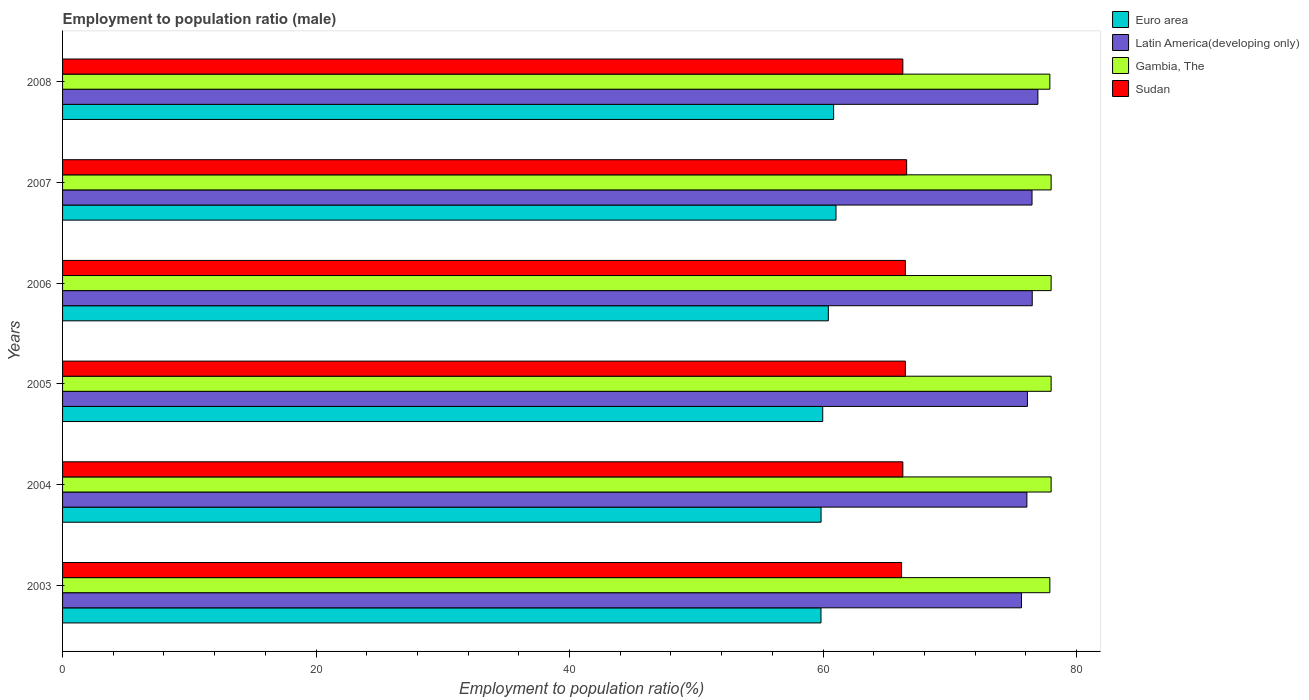How many groups of bars are there?
Give a very brief answer. 6. Are the number of bars per tick equal to the number of legend labels?
Keep it short and to the point. Yes. Are the number of bars on each tick of the Y-axis equal?
Provide a succinct answer. Yes. How many bars are there on the 6th tick from the top?
Offer a terse response. 4. How many bars are there on the 4th tick from the bottom?
Offer a very short reply. 4. In how many cases, is the number of bars for a given year not equal to the number of legend labels?
Provide a short and direct response. 0. What is the employment to population ratio in Sudan in 2004?
Give a very brief answer. 66.3. Across all years, what is the maximum employment to population ratio in Sudan?
Your answer should be compact. 66.6. Across all years, what is the minimum employment to population ratio in Latin America(developing only)?
Offer a terse response. 75.66. What is the total employment to population ratio in Euro area in the graph?
Give a very brief answer. 361.95. What is the difference between the employment to population ratio in Euro area in 2003 and that in 2004?
Give a very brief answer. -0.01. What is the difference between the employment to population ratio in Euro area in 2004 and the employment to population ratio in Gambia, The in 2008?
Your response must be concise. -18.05. What is the average employment to population ratio in Gambia, The per year?
Ensure brevity in your answer.  77.97. In the year 2006, what is the difference between the employment to population ratio in Gambia, The and employment to population ratio in Sudan?
Your answer should be very brief. 11.5. What is the ratio of the employment to population ratio in Sudan in 2003 to that in 2006?
Provide a succinct answer. 1. Is the employment to population ratio in Euro area in 2003 less than that in 2005?
Make the answer very short. Yes. What is the difference between the highest and the second highest employment to population ratio in Sudan?
Your answer should be very brief. 0.1. What is the difference between the highest and the lowest employment to population ratio in Euro area?
Your answer should be compact. 1.18. In how many years, is the employment to population ratio in Sudan greater than the average employment to population ratio in Sudan taken over all years?
Keep it short and to the point. 3. Is the sum of the employment to population ratio in Sudan in 2003 and 2007 greater than the maximum employment to population ratio in Latin America(developing only) across all years?
Your response must be concise. Yes. What does the 3rd bar from the top in 2003 represents?
Your answer should be very brief. Latin America(developing only). What does the 3rd bar from the bottom in 2005 represents?
Your response must be concise. Gambia, The. Is it the case that in every year, the sum of the employment to population ratio in Sudan and employment to population ratio in Euro area is greater than the employment to population ratio in Latin America(developing only)?
Give a very brief answer. Yes. How many bars are there?
Give a very brief answer. 24. Are all the bars in the graph horizontal?
Give a very brief answer. Yes. How many years are there in the graph?
Ensure brevity in your answer.  6. What is the difference between two consecutive major ticks on the X-axis?
Provide a short and direct response. 20. Does the graph contain any zero values?
Your response must be concise. No. Does the graph contain grids?
Provide a succinct answer. No. What is the title of the graph?
Provide a succinct answer. Employment to population ratio (male). What is the Employment to population ratio(%) of Euro area in 2003?
Your response must be concise. 59.84. What is the Employment to population ratio(%) of Latin America(developing only) in 2003?
Give a very brief answer. 75.66. What is the Employment to population ratio(%) in Gambia, The in 2003?
Ensure brevity in your answer.  77.9. What is the Employment to population ratio(%) of Sudan in 2003?
Your answer should be very brief. 66.2. What is the Employment to population ratio(%) in Euro area in 2004?
Your response must be concise. 59.85. What is the Employment to population ratio(%) of Latin America(developing only) in 2004?
Make the answer very short. 76.09. What is the Employment to population ratio(%) in Sudan in 2004?
Your response must be concise. 66.3. What is the Employment to population ratio(%) of Euro area in 2005?
Your response must be concise. 59.98. What is the Employment to population ratio(%) in Latin America(developing only) in 2005?
Provide a succinct answer. 76.13. What is the Employment to population ratio(%) in Gambia, The in 2005?
Offer a terse response. 78. What is the Employment to population ratio(%) in Sudan in 2005?
Provide a short and direct response. 66.5. What is the Employment to population ratio(%) in Euro area in 2006?
Offer a terse response. 60.42. What is the Employment to population ratio(%) in Latin America(developing only) in 2006?
Offer a terse response. 76.51. What is the Employment to population ratio(%) in Gambia, The in 2006?
Make the answer very short. 78. What is the Employment to population ratio(%) of Sudan in 2006?
Your response must be concise. 66.5. What is the Employment to population ratio(%) of Euro area in 2007?
Provide a succinct answer. 61.03. What is the Employment to population ratio(%) of Latin America(developing only) in 2007?
Offer a very short reply. 76.49. What is the Employment to population ratio(%) of Gambia, The in 2007?
Your response must be concise. 78. What is the Employment to population ratio(%) in Sudan in 2007?
Ensure brevity in your answer.  66.6. What is the Employment to population ratio(%) in Euro area in 2008?
Provide a succinct answer. 60.84. What is the Employment to population ratio(%) in Latin America(developing only) in 2008?
Offer a terse response. 76.96. What is the Employment to population ratio(%) in Gambia, The in 2008?
Give a very brief answer. 77.9. What is the Employment to population ratio(%) in Sudan in 2008?
Offer a terse response. 66.3. Across all years, what is the maximum Employment to population ratio(%) of Euro area?
Keep it short and to the point. 61.03. Across all years, what is the maximum Employment to population ratio(%) in Latin America(developing only)?
Provide a short and direct response. 76.96. Across all years, what is the maximum Employment to population ratio(%) in Gambia, The?
Offer a terse response. 78. Across all years, what is the maximum Employment to population ratio(%) of Sudan?
Offer a terse response. 66.6. Across all years, what is the minimum Employment to population ratio(%) of Euro area?
Ensure brevity in your answer.  59.84. Across all years, what is the minimum Employment to population ratio(%) in Latin America(developing only)?
Your answer should be compact. 75.66. Across all years, what is the minimum Employment to population ratio(%) in Gambia, The?
Provide a succinct answer. 77.9. Across all years, what is the minimum Employment to population ratio(%) in Sudan?
Provide a short and direct response. 66.2. What is the total Employment to population ratio(%) in Euro area in the graph?
Provide a short and direct response. 361.95. What is the total Employment to population ratio(%) in Latin America(developing only) in the graph?
Keep it short and to the point. 457.84. What is the total Employment to population ratio(%) of Gambia, The in the graph?
Your answer should be compact. 467.8. What is the total Employment to population ratio(%) in Sudan in the graph?
Keep it short and to the point. 398.4. What is the difference between the Employment to population ratio(%) in Euro area in 2003 and that in 2004?
Make the answer very short. -0.01. What is the difference between the Employment to population ratio(%) of Latin America(developing only) in 2003 and that in 2004?
Make the answer very short. -0.43. What is the difference between the Employment to population ratio(%) in Euro area in 2003 and that in 2005?
Provide a short and direct response. -0.14. What is the difference between the Employment to population ratio(%) of Latin America(developing only) in 2003 and that in 2005?
Make the answer very short. -0.47. What is the difference between the Employment to population ratio(%) of Gambia, The in 2003 and that in 2005?
Provide a short and direct response. -0.1. What is the difference between the Employment to population ratio(%) in Euro area in 2003 and that in 2006?
Offer a terse response. -0.58. What is the difference between the Employment to population ratio(%) of Latin America(developing only) in 2003 and that in 2006?
Offer a very short reply. -0.85. What is the difference between the Employment to population ratio(%) in Gambia, The in 2003 and that in 2006?
Ensure brevity in your answer.  -0.1. What is the difference between the Employment to population ratio(%) in Euro area in 2003 and that in 2007?
Offer a terse response. -1.18. What is the difference between the Employment to population ratio(%) of Latin America(developing only) in 2003 and that in 2007?
Ensure brevity in your answer.  -0.83. What is the difference between the Employment to population ratio(%) in Gambia, The in 2003 and that in 2007?
Ensure brevity in your answer.  -0.1. What is the difference between the Employment to population ratio(%) in Euro area in 2003 and that in 2008?
Make the answer very short. -1. What is the difference between the Employment to population ratio(%) of Latin America(developing only) in 2003 and that in 2008?
Your answer should be very brief. -1.29. What is the difference between the Employment to population ratio(%) of Sudan in 2003 and that in 2008?
Ensure brevity in your answer.  -0.1. What is the difference between the Employment to population ratio(%) in Euro area in 2004 and that in 2005?
Provide a short and direct response. -0.13. What is the difference between the Employment to population ratio(%) of Latin America(developing only) in 2004 and that in 2005?
Your response must be concise. -0.04. What is the difference between the Employment to population ratio(%) of Gambia, The in 2004 and that in 2005?
Make the answer very short. 0. What is the difference between the Employment to population ratio(%) of Euro area in 2004 and that in 2006?
Offer a very short reply. -0.57. What is the difference between the Employment to population ratio(%) of Latin America(developing only) in 2004 and that in 2006?
Provide a succinct answer. -0.42. What is the difference between the Employment to population ratio(%) of Euro area in 2004 and that in 2007?
Offer a very short reply. -1.18. What is the difference between the Employment to population ratio(%) in Latin America(developing only) in 2004 and that in 2007?
Give a very brief answer. -0.41. What is the difference between the Employment to population ratio(%) in Gambia, The in 2004 and that in 2007?
Make the answer very short. 0. What is the difference between the Employment to population ratio(%) in Euro area in 2004 and that in 2008?
Your response must be concise. -0.99. What is the difference between the Employment to population ratio(%) in Latin America(developing only) in 2004 and that in 2008?
Provide a succinct answer. -0.87. What is the difference between the Employment to population ratio(%) of Sudan in 2004 and that in 2008?
Ensure brevity in your answer.  0. What is the difference between the Employment to population ratio(%) of Euro area in 2005 and that in 2006?
Your answer should be compact. -0.44. What is the difference between the Employment to population ratio(%) of Latin America(developing only) in 2005 and that in 2006?
Provide a short and direct response. -0.38. What is the difference between the Employment to population ratio(%) of Gambia, The in 2005 and that in 2006?
Offer a terse response. 0. What is the difference between the Employment to population ratio(%) in Euro area in 2005 and that in 2007?
Your answer should be compact. -1.05. What is the difference between the Employment to population ratio(%) in Latin America(developing only) in 2005 and that in 2007?
Offer a terse response. -0.36. What is the difference between the Employment to population ratio(%) of Euro area in 2005 and that in 2008?
Provide a succinct answer. -0.86. What is the difference between the Employment to population ratio(%) of Latin America(developing only) in 2005 and that in 2008?
Keep it short and to the point. -0.83. What is the difference between the Employment to population ratio(%) in Gambia, The in 2005 and that in 2008?
Keep it short and to the point. 0.1. What is the difference between the Employment to population ratio(%) in Euro area in 2006 and that in 2007?
Your answer should be compact. -0.6. What is the difference between the Employment to population ratio(%) of Latin America(developing only) in 2006 and that in 2007?
Your answer should be very brief. 0.02. What is the difference between the Employment to population ratio(%) of Euro area in 2006 and that in 2008?
Provide a short and direct response. -0.42. What is the difference between the Employment to population ratio(%) of Latin America(developing only) in 2006 and that in 2008?
Offer a terse response. -0.45. What is the difference between the Employment to population ratio(%) of Sudan in 2006 and that in 2008?
Offer a very short reply. 0.2. What is the difference between the Employment to population ratio(%) of Euro area in 2007 and that in 2008?
Offer a terse response. 0.19. What is the difference between the Employment to population ratio(%) of Latin America(developing only) in 2007 and that in 2008?
Ensure brevity in your answer.  -0.46. What is the difference between the Employment to population ratio(%) in Sudan in 2007 and that in 2008?
Make the answer very short. 0.3. What is the difference between the Employment to population ratio(%) in Euro area in 2003 and the Employment to population ratio(%) in Latin America(developing only) in 2004?
Provide a succinct answer. -16.25. What is the difference between the Employment to population ratio(%) of Euro area in 2003 and the Employment to population ratio(%) of Gambia, The in 2004?
Make the answer very short. -18.16. What is the difference between the Employment to population ratio(%) of Euro area in 2003 and the Employment to population ratio(%) of Sudan in 2004?
Keep it short and to the point. -6.46. What is the difference between the Employment to population ratio(%) in Latin America(developing only) in 2003 and the Employment to population ratio(%) in Gambia, The in 2004?
Provide a succinct answer. -2.34. What is the difference between the Employment to population ratio(%) of Latin America(developing only) in 2003 and the Employment to population ratio(%) of Sudan in 2004?
Your response must be concise. 9.36. What is the difference between the Employment to population ratio(%) in Euro area in 2003 and the Employment to population ratio(%) in Latin America(developing only) in 2005?
Provide a succinct answer. -16.29. What is the difference between the Employment to population ratio(%) of Euro area in 2003 and the Employment to population ratio(%) of Gambia, The in 2005?
Make the answer very short. -18.16. What is the difference between the Employment to population ratio(%) of Euro area in 2003 and the Employment to population ratio(%) of Sudan in 2005?
Offer a very short reply. -6.66. What is the difference between the Employment to population ratio(%) in Latin America(developing only) in 2003 and the Employment to population ratio(%) in Gambia, The in 2005?
Provide a succinct answer. -2.34. What is the difference between the Employment to population ratio(%) of Latin America(developing only) in 2003 and the Employment to population ratio(%) of Sudan in 2005?
Offer a terse response. 9.16. What is the difference between the Employment to population ratio(%) of Euro area in 2003 and the Employment to population ratio(%) of Latin America(developing only) in 2006?
Give a very brief answer. -16.67. What is the difference between the Employment to population ratio(%) of Euro area in 2003 and the Employment to population ratio(%) of Gambia, The in 2006?
Your answer should be very brief. -18.16. What is the difference between the Employment to population ratio(%) in Euro area in 2003 and the Employment to population ratio(%) in Sudan in 2006?
Provide a short and direct response. -6.66. What is the difference between the Employment to population ratio(%) in Latin America(developing only) in 2003 and the Employment to population ratio(%) in Gambia, The in 2006?
Make the answer very short. -2.34. What is the difference between the Employment to population ratio(%) in Latin America(developing only) in 2003 and the Employment to population ratio(%) in Sudan in 2006?
Keep it short and to the point. 9.16. What is the difference between the Employment to population ratio(%) in Euro area in 2003 and the Employment to population ratio(%) in Latin America(developing only) in 2007?
Offer a very short reply. -16.65. What is the difference between the Employment to population ratio(%) in Euro area in 2003 and the Employment to population ratio(%) in Gambia, The in 2007?
Offer a very short reply. -18.16. What is the difference between the Employment to population ratio(%) in Euro area in 2003 and the Employment to population ratio(%) in Sudan in 2007?
Your answer should be compact. -6.76. What is the difference between the Employment to population ratio(%) in Latin America(developing only) in 2003 and the Employment to population ratio(%) in Gambia, The in 2007?
Provide a short and direct response. -2.34. What is the difference between the Employment to population ratio(%) in Latin America(developing only) in 2003 and the Employment to population ratio(%) in Sudan in 2007?
Your answer should be very brief. 9.06. What is the difference between the Employment to population ratio(%) in Euro area in 2003 and the Employment to population ratio(%) in Latin America(developing only) in 2008?
Give a very brief answer. -17.11. What is the difference between the Employment to population ratio(%) in Euro area in 2003 and the Employment to population ratio(%) in Gambia, The in 2008?
Your answer should be very brief. -18.06. What is the difference between the Employment to population ratio(%) in Euro area in 2003 and the Employment to population ratio(%) in Sudan in 2008?
Your answer should be compact. -6.46. What is the difference between the Employment to population ratio(%) of Latin America(developing only) in 2003 and the Employment to population ratio(%) of Gambia, The in 2008?
Your answer should be compact. -2.24. What is the difference between the Employment to population ratio(%) of Latin America(developing only) in 2003 and the Employment to population ratio(%) of Sudan in 2008?
Ensure brevity in your answer.  9.36. What is the difference between the Employment to population ratio(%) of Euro area in 2004 and the Employment to population ratio(%) of Latin America(developing only) in 2005?
Provide a succinct answer. -16.28. What is the difference between the Employment to population ratio(%) in Euro area in 2004 and the Employment to population ratio(%) in Gambia, The in 2005?
Make the answer very short. -18.15. What is the difference between the Employment to population ratio(%) in Euro area in 2004 and the Employment to population ratio(%) in Sudan in 2005?
Your response must be concise. -6.65. What is the difference between the Employment to population ratio(%) in Latin America(developing only) in 2004 and the Employment to population ratio(%) in Gambia, The in 2005?
Offer a very short reply. -1.91. What is the difference between the Employment to population ratio(%) of Latin America(developing only) in 2004 and the Employment to population ratio(%) of Sudan in 2005?
Your answer should be compact. 9.59. What is the difference between the Employment to population ratio(%) in Euro area in 2004 and the Employment to population ratio(%) in Latin America(developing only) in 2006?
Give a very brief answer. -16.66. What is the difference between the Employment to population ratio(%) of Euro area in 2004 and the Employment to population ratio(%) of Gambia, The in 2006?
Keep it short and to the point. -18.15. What is the difference between the Employment to population ratio(%) in Euro area in 2004 and the Employment to population ratio(%) in Sudan in 2006?
Your response must be concise. -6.65. What is the difference between the Employment to population ratio(%) of Latin America(developing only) in 2004 and the Employment to population ratio(%) of Gambia, The in 2006?
Make the answer very short. -1.91. What is the difference between the Employment to population ratio(%) of Latin America(developing only) in 2004 and the Employment to population ratio(%) of Sudan in 2006?
Keep it short and to the point. 9.59. What is the difference between the Employment to population ratio(%) of Gambia, The in 2004 and the Employment to population ratio(%) of Sudan in 2006?
Your response must be concise. 11.5. What is the difference between the Employment to population ratio(%) in Euro area in 2004 and the Employment to population ratio(%) in Latin America(developing only) in 2007?
Provide a short and direct response. -16.65. What is the difference between the Employment to population ratio(%) in Euro area in 2004 and the Employment to population ratio(%) in Gambia, The in 2007?
Give a very brief answer. -18.15. What is the difference between the Employment to population ratio(%) in Euro area in 2004 and the Employment to population ratio(%) in Sudan in 2007?
Keep it short and to the point. -6.75. What is the difference between the Employment to population ratio(%) in Latin America(developing only) in 2004 and the Employment to population ratio(%) in Gambia, The in 2007?
Offer a terse response. -1.91. What is the difference between the Employment to population ratio(%) in Latin America(developing only) in 2004 and the Employment to population ratio(%) in Sudan in 2007?
Ensure brevity in your answer.  9.49. What is the difference between the Employment to population ratio(%) in Gambia, The in 2004 and the Employment to population ratio(%) in Sudan in 2007?
Your answer should be compact. 11.4. What is the difference between the Employment to population ratio(%) in Euro area in 2004 and the Employment to population ratio(%) in Latin America(developing only) in 2008?
Your response must be concise. -17.11. What is the difference between the Employment to population ratio(%) in Euro area in 2004 and the Employment to population ratio(%) in Gambia, The in 2008?
Provide a succinct answer. -18.05. What is the difference between the Employment to population ratio(%) in Euro area in 2004 and the Employment to population ratio(%) in Sudan in 2008?
Your response must be concise. -6.45. What is the difference between the Employment to population ratio(%) in Latin America(developing only) in 2004 and the Employment to population ratio(%) in Gambia, The in 2008?
Ensure brevity in your answer.  -1.81. What is the difference between the Employment to population ratio(%) in Latin America(developing only) in 2004 and the Employment to population ratio(%) in Sudan in 2008?
Give a very brief answer. 9.79. What is the difference between the Employment to population ratio(%) of Gambia, The in 2004 and the Employment to population ratio(%) of Sudan in 2008?
Keep it short and to the point. 11.7. What is the difference between the Employment to population ratio(%) in Euro area in 2005 and the Employment to population ratio(%) in Latin America(developing only) in 2006?
Keep it short and to the point. -16.53. What is the difference between the Employment to population ratio(%) of Euro area in 2005 and the Employment to population ratio(%) of Gambia, The in 2006?
Provide a succinct answer. -18.02. What is the difference between the Employment to population ratio(%) in Euro area in 2005 and the Employment to population ratio(%) in Sudan in 2006?
Offer a terse response. -6.52. What is the difference between the Employment to population ratio(%) in Latin America(developing only) in 2005 and the Employment to population ratio(%) in Gambia, The in 2006?
Ensure brevity in your answer.  -1.87. What is the difference between the Employment to population ratio(%) in Latin America(developing only) in 2005 and the Employment to population ratio(%) in Sudan in 2006?
Offer a very short reply. 9.63. What is the difference between the Employment to population ratio(%) in Euro area in 2005 and the Employment to population ratio(%) in Latin America(developing only) in 2007?
Your answer should be very brief. -16.52. What is the difference between the Employment to population ratio(%) in Euro area in 2005 and the Employment to population ratio(%) in Gambia, The in 2007?
Your response must be concise. -18.02. What is the difference between the Employment to population ratio(%) of Euro area in 2005 and the Employment to population ratio(%) of Sudan in 2007?
Make the answer very short. -6.62. What is the difference between the Employment to population ratio(%) of Latin America(developing only) in 2005 and the Employment to population ratio(%) of Gambia, The in 2007?
Your answer should be compact. -1.87. What is the difference between the Employment to population ratio(%) in Latin America(developing only) in 2005 and the Employment to population ratio(%) in Sudan in 2007?
Give a very brief answer. 9.53. What is the difference between the Employment to population ratio(%) of Gambia, The in 2005 and the Employment to population ratio(%) of Sudan in 2007?
Keep it short and to the point. 11.4. What is the difference between the Employment to population ratio(%) of Euro area in 2005 and the Employment to population ratio(%) of Latin America(developing only) in 2008?
Provide a short and direct response. -16.98. What is the difference between the Employment to population ratio(%) of Euro area in 2005 and the Employment to population ratio(%) of Gambia, The in 2008?
Give a very brief answer. -17.92. What is the difference between the Employment to population ratio(%) in Euro area in 2005 and the Employment to population ratio(%) in Sudan in 2008?
Offer a terse response. -6.32. What is the difference between the Employment to population ratio(%) of Latin America(developing only) in 2005 and the Employment to population ratio(%) of Gambia, The in 2008?
Make the answer very short. -1.77. What is the difference between the Employment to population ratio(%) of Latin America(developing only) in 2005 and the Employment to population ratio(%) of Sudan in 2008?
Your response must be concise. 9.83. What is the difference between the Employment to population ratio(%) in Gambia, The in 2005 and the Employment to population ratio(%) in Sudan in 2008?
Give a very brief answer. 11.7. What is the difference between the Employment to population ratio(%) of Euro area in 2006 and the Employment to population ratio(%) of Latin America(developing only) in 2007?
Give a very brief answer. -16.07. What is the difference between the Employment to population ratio(%) in Euro area in 2006 and the Employment to population ratio(%) in Gambia, The in 2007?
Your answer should be compact. -17.58. What is the difference between the Employment to population ratio(%) in Euro area in 2006 and the Employment to population ratio(%) in Sudan in 2007?
Your answer should be compact. -6.18. What is the difference between the Employment to population ratio(%) of Latin America(developing only) in 2006 and the Employment to population ratio(%) of Gambia, The in 2007?
Keep it short and to the point. -1.49. What is the difference between the Employment to population ratio(%) of Latin America(developing only) in 2006 and the Employment to population ratio(%) of Sudan in 2007?
Your answer should be very brief. 9.91. What is the difference between the Employment to population ratio(%) in Gambia, The in 2006 and the Employment to population ratio(%) in Sudan in 2007?
Make the answer very short. 11.4. What is the difference between the Employment to population ratio(%) in Euro area in 2006 and the Employment to population ratio(%) in Latin America(developing only) in 2008?
Keep it short and to the point. -16.53. What is the difference between the Employment to population ratio(%) of Euro area in 2006 and the Employment to population ratio(%) of Gambia, The in 2008?
Offer a terse response. -17.48. What is the difference between the Employment to population ratio(%) in Euro area in 2006 and the Employment to population ratio(%) in Sudan in 2008?
Your answer should be compact. -5.88. What is the difference between the Employment to population ratio(%) in Latin America(developing only) in 2006 and the Employment to population ratio(%) in Gambia, The in 2008?
Give a very brief answer. -1.39. What is the difference between the Employment to population ratio(%) of Latin America(developing only) in 2006 and the Employment to population ratio(%) of Sudan in 2008?
Your answer should be very brief. 10.21. What is the difference between the Employment to population ratio(%) of Euro area in 2007 and the Employment to population ratio(%) of Latin America(developing only) in 2008?
Keep it short and to the point. -15.93. What is the difference between the Employment to population ratio(%) in Euro area in 2007 and the Employment to population ratio(%) in Gambia, The in 2008?
Your response must be concise. -16.87. What is the difference between the Employment to population ratio(%) of Euro area in 2007 and the Employment to population ratio(%) of Sudan in 2008?
Give a very brief answer. -5.27. What is the difference between the Employment to population ratio(%) of Latin America(developing only) in 2007 and the Employment to population ratio(%) of Gambia, The in 2008?
Your answer should be very brief. -1.41. What is the difference between the Employment to population ratio(%) in Latin America(developing only) in 2007 and the Employment to population ratio(%) in Sudan in 2008?
Offer a very short reply. 10.19. What is the average Employment to population ratio(%) of Euro area per year?
Make the answer very short. 60.33. What is the average Employment to population ratio(%) of Latin America(developing only) per year?
Keep it short and to the point. 76.31. What is the average Employment to population ratio(%) of Gambia, The per year?
Ensure brevity in your answer.  77.97. What is the average Employment to population ratio(%) of Sudan per year?
Keep it short and to the point. 66.4. In the year 2003, what is the difference between the Employment to population ratio(%) of Euro area and Employment to population ratio(%) of Latin America(developing only)?
Offer a very short reply. -15.82. In the year 2003, what is the difference between the Employment to population ratio(%) in Euro area and Employment to population ratio(%) in Gambia, The?
Your answer should be very brief. -18.06. In the year 2003, what is the difference between the Employment to population ratio(%) in Euro area and Employment to population ratio(%) in Sudan?
Your response must be concise. -6.36. In the year 2003, what is the difference between the Employment to population ratio(%) of Latin America(developing only) and Employment to population ratio(%) of Gambia, The?
Provide a short and direct response. -2.24. In the year 2003, what is the difference between the Employment to population ratio(%) in Latin America(developing only) and Employment to population ratio(%) in Sudan?
Provide a short and direct response. 9.46. In the year 2004, what is the difference between the Employment to population ratio(%) in Euro area and Employment to population ratio(%) in Latin America(developing only)?
Provide a succinct answer. -16.24. In the year 2004, what is the difference between the Employment to population ratio(%) in Euro area and Employment to population ratio(%) in Gambia, The?
Your response must be concise. -18.15. In the year 2004, what is the difference between the Employment to population ratio(%) of Euro area and Employment to population ratio(%) of Sudan?
Your response must be concise. -6.45. In the year 2004, what is the difference between the Employment to population ratio(%) of Latin America(developing only) and Employment to population ratio(%) of Gambia, The?
Provide a short and direct response. -1.91. In the year 2004, what is the difference between the Employment to population ratio(%) in Latin America(developing only) and Employment to population ratio(%) in Sudan?
Your response must be concise. 9.79. In the year 2005, what is the difference between the Employment to population ratio(%) of Euro area and Employment to population ratio(%) of Latin America(developing only)?
Provide a short and direct response. -16.15. In the year 2005, what is the difference between the Employment to population ratio(%) in Euro area and Employment to population ratio(%) in Gambia, The?
Ensure brevity in your answer.  -18.02. In the year 2005, what is the difference between the Employment to population ratio(%) of Euro area and Employment to population ratio(%) of Sudan?
Your answer should be compact. -6.52. In the year 2005, what is the difference between the Employment to population ratio(%) of Latin America(developing only) and Employment to population ratio(%) of Gambia, The?
Make the answer very short. -1.87. In the year 2005, what is the difference between the Employment to population ratio(%) of Latin America(developing only) and Employment to population ratio(%) of Sudan?
Your answer should be very brief. 9.63. In the year 2005, what is the difference between the Employment to population ratio(%) of Gambia, The and Employment to population ratio(%) of Sudan?
Ensure brevity in your answer.  11.5. In the year 2006, what is the difference between the Employment to population ratio(%) of Euro area and Employment to population ratio(%) of Latin America(developing only)?
Keep it short and to the point. -16.09. In the year 2006, what is the difference between the Employment to population ratio(%) of Euro area and Employment to population ratio(%) of Gambia, The?
Offer a terse response. -17.58. In the year 2006, what is the difference between the Employment to population ratio(%) in Euro area and Employment to population ratio(%) in Sudan?
Give a very brief answer. -6.08. In the year 2006, what is the difference between the Employment to population ratio(%) in Latin America(developing only) and Employment to population ratio(%) in Gambia, The?
Give a very brief answer. -1.49. In the year 2006, what is the difference between the Employment to population ratio(%) of Latin America(developing only) and Employment to population ratio(%) of Sudan?
Provide a succinct answer. 10.01. In the year 2007, what is the difference between the Employment to population ratio(%) in Euro area and Employment to population ratio(%) in Latin America(developing only)?
Provide a short and direct response. -15.47. In the year 2007, what is the difference between the Employment to population ratio(%) in Euro area and Employment to population ratio(%) in Gambia, The?
Your response must be concise. -16.97. In the year 2007, what is the difference between the Employment to population ratio(%) of Euro area and Employment to population ratio(%) of Sudan?
Make the answer very short. -5.57. In the year 2007, what is the difference between the Employment to population ratio(%) in Latin America(developing only) and Employment to population ratio(%) in Gambia, The?
Ensure brevity in your answer.  -1.51. In the year 2007, what is the difference between the Employment to population ratio(%) in Latin America(developing only) and Employment to population ratio(%) in Sudan?
Keep it short and to the point. 9.89. In the year 2007, what is the difference between the Employment to population ratio(%) in Gambia, The and Employment to population ratio(%) in Sudan?
Provide a succinct answer. 11.4. In the year 2008, what is the difference between the Employment to population ratio(%) of Euro area and Employment to population ratio(%) of Latin America(developing only)?
Your answer should be compact. -16.12. In the year 2008, what is the difference between the Employment to population ratio(%) of Euro area and Employment to population ratio(%) of Gambia, The?
Give a very brief answer. -17.06. In the year 2008, what is the difference between the Employment to population ratio(%) in Euro area and Employment to population ratio(%) in Sudan?
Give a very brief answer. -5.46. In the year 2008, what is the difference between the Employment to population ratio(%) in Latin America(developing only) and Employment to population ratio(%) in Gambia, The?
Offer a terse response. -0.94. In the year 2008, what is the difference between the Employment to population ratio(%) in Latin America(developing only) and Employment to population ratio(%) in Sudan?
Give a very brief answer. 10.66. In the year 2008, what is the difference between the Employment to population ratio(%) in Gambia, The and Employment to population ratio(%) in Sudan?
Make the answer very short. 11.6. What is the ratio of the Employment to population ratio(%) in Latin America(developing only) in 2003 to that in 2004?
Make the answer very short. 0.99. What is the ratio of the Employment to population ratio(%) of Sudan in 2003 to that in 2004?
Your answer should be compact. 1. What is the ratio of the Employment to population ratio(%) in Latin America(developing only) in 2003 to that in 2005?
Give a very brief answer. 0.99. What is the ratio of the Employment to population ratio(%) of Gambia, The in 2003 to that in 2005?
Provide a succinct answer. 1. What is the ratio of the Employment to population ratio(%) in Sudan in 2003 to that in 2005?
Keep it short and to the point. 1. What is the ratio of the Employment to population ratio(%) of Latin America(developing only) in 2003 to that in 2006?
Your answer should be very brief. 0.99. What is the ratio of the Employment to population ratio(%) in Euro area in 2003 to that in 2007?
Offer a terse response. 0.98. What is the ratio of the Employment to population ratio(%) in Gambia, The in 2003 to that in 2007?
Make the answer very short. 1. What is the ratio of the Employment to population ratio(%) of Euro area in 2003 to that in 2008?
Ensure brevity in your answer.  0.98. What is the ratio of the Employment to population ratio(%) of Latin America(developing only) in 2003 to that in 2008?
Ensure brevity in your answer.  0.98. What is the ratio of the Employment to population ratio(%) of Gambia, The in 2004 to that in 2005?
Ensure brevity in your answer.  1. What is the ratio of the Employment to population ratio(%) of Sudan in 2004 to that in 2005?
Offer a very short reply. 1. What is the ratio of the Employment to population ratio(%) of Gambia, The in 2004 to that in 2006?
Keep it short and to the point. 1. What is the ratio of the Employment to population ratio(%) in Euro area in 2004 to that in 2007?
Your answer should be compact. 0.98. What is the ratio of the Employment to population ratio(%) of Gambia, The in 2004 to that in 2007?
Give a very brief answer. 1. What is the ratio of the Employment to population ratio(%) in Euro area in 2004 to that in 2008?
Your response must be concise. 0.98. What is the ratio of the Employment to population ratio(%) of Latin America(developing only) in 2004 to that in 2008?
Provide a succinct answer. 0.99. What is the ratio of the Employment to population ratio(%) of Sudan in 2004 to that in 2008?
Your answer should be compact. 1. What is the ratio of the Employment to population ratio(%) in Latin America(developing only) in 2005 to that in 2006?
Offer a very short reply. 0.99. What is the ratio of the Employment to population ratio(%) of Euro area in 2005 to that in 2007?
Offer a very short reply. 0.98. What is the ratio of the Employment to population ratio(%) of Sudan in 2005 to that in 2007?
Your answer should be compact. 1. What is the ratio of the Employment to population ratio(%) of Euro area in 2005 to that in 2008?
Give a very brief answer. 0.99. What is the ratio of the Employment to population ratio(%) in Latin America(developing only) in 2005 to that in 2008?
Your answer should be compact. 0.99. What is the ratio of the Employment to population ratio(%) in Sudan in 2005 to that in 2008?
Make the answer very short. 1. What is the ratio of the Employment to population ratio(%) of Gambia, The in 2006 to that in 2007?
Offer a terse response. 1. What is the ratio of the Employment to population ratio(%) of Sudan in 2006 to that in 2007?
Give a very brief answer. 1. What is the ratio of the Employment to population ratio(%) in Euro area in 2006 to that in 2008?
Give a very brief answer. 0.99. What is the ratio of the Employment to population ratio(%) in Gambia, The in 2006 to that in 2008?
Make the answer very short. 1. What is the ratio of the Employment to population ratio(%) in Euro area in 2007 to that in 2008?
Give a very brief answer. 1. What is the ratio of the Employment to population ratio(%) of Sudan in 2007 to that in 2008?
Your answer should be compact. 1. What is the difference between the highest and the second highest Employment to population ratio(%) of Euro area?
Offer a terse response. 0.19. What is the difference between the highest and the second highest Employment to population ratio(%) of Latin America(developing only)?
Your response must be concise. 0.45. What is the difference between the highest and the second highest Employment to population ratio(%) of Gambia, The?
Give a very brief answer. 0. What is the difference between the highest and the lowest Employment to population ratio(%) in Euro area?
Offer a very short reply. 1.18. What is the difference between the highest and the lowest Employment to population ratio(%) in Latin America(developing only)?
Offer a terse response. 1.29. What is the difference between the highest and the lowest Employment to population ratio(%) in Gambia, The?
Provide a short and direct response. 0.1. 